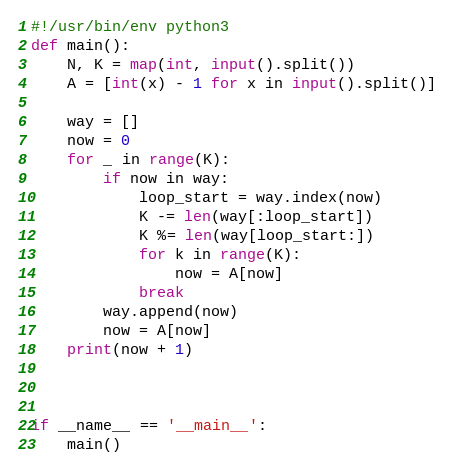<code> <loc_0><loc_0><loc_500><loc_500><_Python_>#!/usr/bin/env python3
def main():
    N, K = map(int, input().split())
    A = [int(x) - 1 for x in input().split()]

    way = []
    now = 0
    for _ in range(K):
        if now in way:
            loop_start = way.index(now)
            K -= len(way[:loop_start])
            K %= len(way[loop_start:])
            for k in range(K):
                now = A[now]
            break
        way.append(now)
        now = A[now]
    print(now + 1)



if __name__ == '__main__':
    main()
</code> 